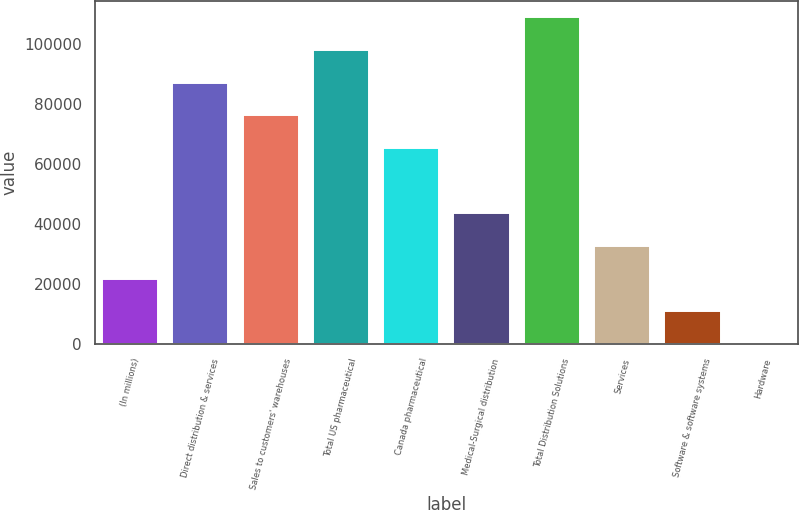Convert chart. <chart><loc_0><loc_0><loc_500><loc_500><bar_chart><fcel>(In millions)<fcel>Direct distribution & services<fcel>Sales to customers' warehouses<fcel>Total US pharmaceutical<fcel>Canada pharmaceutical<fcel>Medical-Surgical distribution<fcel>Total Distribution Solutions<fcel>Services<fcel>Software & software systems<fcel>Hardware<nl><fcel>21831.6<fcel>86984.4<fcel>76125.6<fcel>97843.2<fcel>65266.8<fcel>43549.2<fcel>108702<fcel>32690.4<fcel>10972.8<fcel>114<nl></chart> 